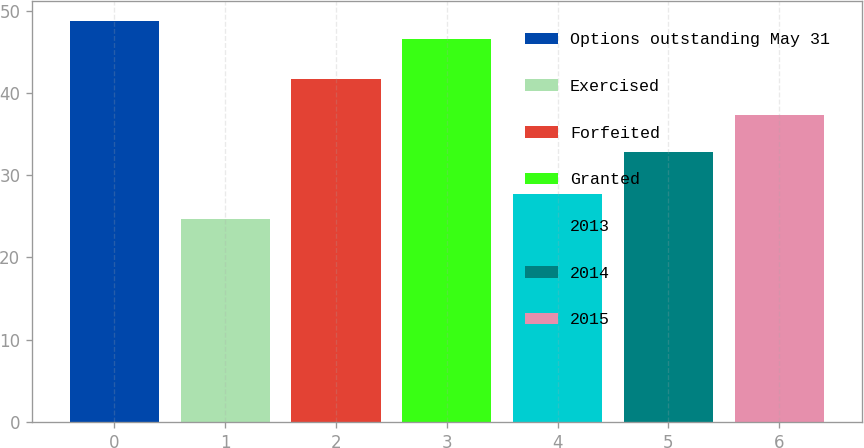Convert chart to OTSL. <chart><loc_0><loc_0><loc_500><loc_500><bar_chart><fcel>Options outstanding May 31<fcel>Exercised<fcel>Forfeited<fcel>Granted<fcel>2013<fcel>2014<fcel>2015<nl><fcel>48.78<fcel>24.7<fcel>41.74<fcel>46.55<fcel>27.7<fcel>32.82<fcel>37.28<nl></chart> 